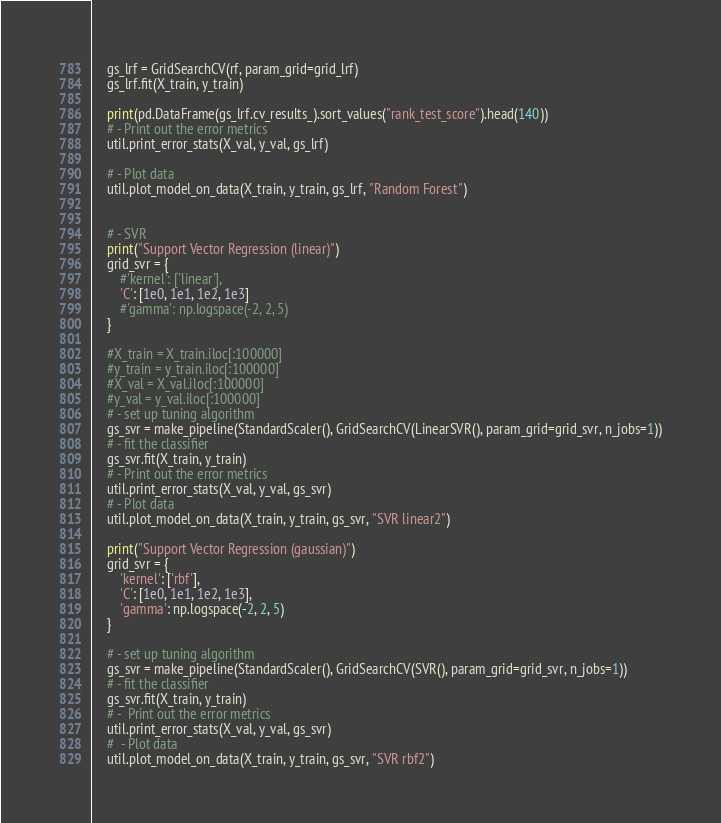Convert code to text. <code><loc_0><loc_0><loc_500><loc_500><_Python_>
    gs_lrf = GridSearchCV(rf, param_grid=grid_lrf)
    gs_lrf.fit(X_train, y_train)

    print(pd.DataFrame(gs_lrf.cv_results_).sort_values("rank_test_score").head(140))
    # - Print out the error metrics
    util.print_error_stats(X_val, y_val, gs_lrf)

    # - Plot data
    util.plot_model_on_data(X_train, y_train, gs_lrf, "Random Forest")
    
    
    # - SVR
    print("Support Vector Regression (linear)")
    grid_svr = {
        #'kernel': ['linear'],
        'C': [1e0, 1e1, 1e2, 1e3]
        #'gamma': np.logspace(-2, 2, 5)
    }

    #X_train = X_train.iloc[:100000]
    #y_train = y_train.iloc[:100000]
    #X_val = X_val.iloc[:100000]
    #y_val = y_val.iloc[:100000]
    # - set up tuning algorithm
    gs_svr = make_pipeline(StandardScaler(), GridSearchCV(LinearSVR(), param_grid=grid_svr, n_jobs=1))
    # - fit the classifier
    gs_svr.fit(X_train, y_train)
    # - Print out the error metrics
    util.print_error_stats(X_val, y_val, gs_svr)
    # - Plot data
    util.plot_model_on_data(X_train, y_train, gs_svr, "SVR linear2")

    print("Support Vector Regression (gaussian)")
    grid_svr = {
        'kernel': ['rbf'],
        'C': [1e0, 1e1, 1e2, 1e3],
        'gamma': np.logspace(-2, 2, 5)
    }

    # - set up tuning algorithm
    gs_svr = make_pipeline(StandardScaler(), GridSearchCV(SVR(), param_grid=grid_svr, n_jobs=1))
    # - fit the classifier
    gs_svr.fit(X_train, y_train)
    # -  Print out the error metrics
    util.print_error_stats(X_val, y_val, gs_svr)
    #  - Plot data
    util.plot_model_on_data(X_train, y_train, gs_svr, "SVR rbf2")
</code> 